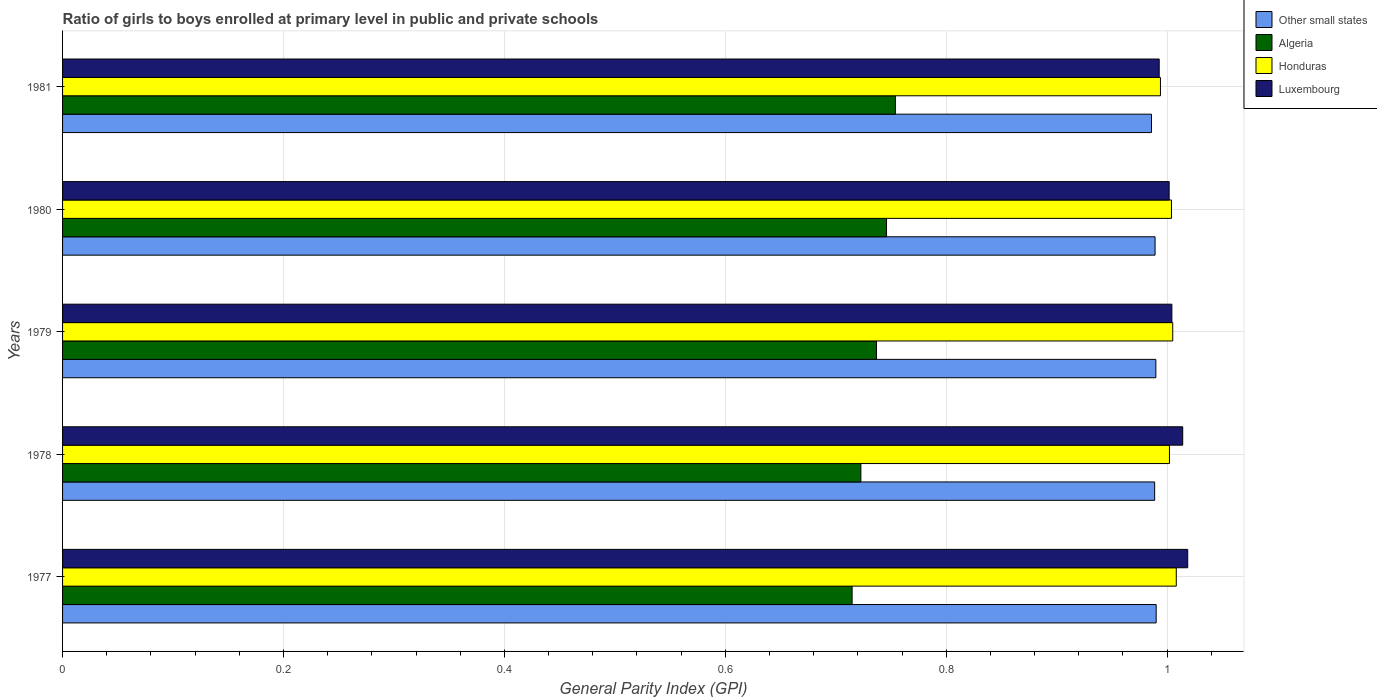How many different coloured bars are there?
Your answer should be very brief. 4. Are the number of bars per tick equal to the number of legend labels?
Offer a very short reply. Yes. How many bars are there on the 2nd tick from the top?
Give a very brief answer. 4. How many bars are there on the 2nd tick from the bottom?
Make the answer very short. 4. What is the label of the 4th group of bars from the top?
Give a very brief answer. 1978. In how many cases, is the number of bars for a given year not equal to the number of legend labels?
Keep it short and to the point. 0. What is the general parity index in Honduras in 1979?
Your answer should be compact. 1.01. Across all years, what is the maximum general parity index in Other small states?
Your answer should be very brief. 0.99. Across all years, what is the minimum general parity index in Honduras?
Keep it short and to the point. 0.99. In which year was the general parity index in Other small states maximum?
Offer a terse response. 1977. In which year was the general parity index in Luxembourg minimum?
Your answer should be compact. 1981. What is the total general parity index in Algeria in the graph?
Provide a succinct answer. 3.67. What is the difference between the general parity index in Honduras in 1979 and that in 1981?
Keep it short and to the point. 0.01. What is the difference between the general parity index in Other small states in 1979 and the general parity index in Luxembourg in 1978?
Your response must be concise. -0.02. What is the average general parity index in Luxembourg per year?
Your answer should be compact. 1.01. In the year 1979, what is the difference between the general parity index in Honduras and general parity index in Algeria?
Provide a succinct answer. 0.27. What is the ratio of the general parity index in Algeria in 1977 to that in 1981?
Make the answer very short. 0.95. Is the general parity index in Algeria in 1977 less than that in 1978?
Offer a very short reply. Yes. What is the difference between the highest and the second highest general parity index in Algeria?
Offer a terse response. 0.01. What is the difference between the highest and the lowest general parity index in Other small states?
Your answer should be very brief. 0. What does the 4th bar from the top in 1981 represents?
Provide a succinct answer. Other small states. What does the 1st bar from the bottom in 1979 represents?
Your response must be concise. Other small states. Is it the case that in every year, the sum of the general parity index in Other small states and general parity index in Algeria is greater than the general parity index in Honduras?
Offer a very short reply. Yes. How many bars are there?
Make the answer very short. 20. Are all the bars in the graph horizontal?
Ensure brevity in your answer.  Yes. How many years are there in the graph?
Offer a terse response. 5. What is the difference between two consecutive major ticks on the X-axis?
Your response must be concise. 0.2. Are the values on the major ticks of X-axis written in scientific E-notation?
Ensure brevity in your answer.  No. Does the graph contain any zero values?
Your response must be concise. No. Does the graph contain grids?
Your answer should be compact. Yes. Where does the legend appear in the graph?
Your answer should be very brief. Top right. What is the title of the graph?
Keep it short and to the point. Ratio of girls to boys enrolled at primary level in public and private schools. Does "French Polynesia" appear as one of the legend labels in the graph?
Provide a succinct answer. No. What is the label or title of the X-axis?
Offer a terse response. General Parity Index (GPI). What is the label or title of the Y-axis?
Ensure brevity in your answer.  Years. What is the General Parity Index (GPI) of Other small states in 1977?
Ensure brevity in your answer.  0.99. What is the General Parity Index (GPI) of Algeria in 1977?
Offer a terse response. 0.71. What is the General Parity Index (GPI) of Honduras in 1977?
Ensure brevity in your answer.  1.01. What is the General Parity Index (GPI) in Luxembourg in 1977?
Provide a succinct answer. 1.02. What is the General Parity Index (GPI) in Other small states in 1978?
Provide a succinct answer. 0.99. What is the General Parity Index (GPI) of Algeria in 1978?
Provide a succinct answer. 0.72. What is the General Parity Index (GPI) in Honduras in 1978?
Your response must be concise. 1. What is the General Parity Index (GPI) of Luxembourg in 1978?
Provide a short and direct response. 1.01. What is the General Parity Index (GPI) in Other small states in 1979?
Offer a very short reply. 0.99. What is the General Parity Index (GPI) of Algeria in 1979?
Make the answer very short. 0.74. What is the General Parity Index (GPI) of Honduras in 1979?
Provide a succinct answer. 1.01. What is the General Parity Index (GPI) of Luxembourg in 1979?
Keep it short and to the point. 1. What is the General Parity Index (GPI) of Other small states in 1980?
Ensure brevity in your answer.  0.99. What is the General Parity Index (GPI) of Algeria in 1980?
Offer a very short reply. 0.75. What is the General Parity Index (GPI) of Honduras in 1980?
Offer a very short reply. 1. What is the General Parity Index (GPI) of Luxembourg in 1980?
Offer a terse response. 1. What is the General Parity Index (GPI) of Other small states in 1981?
Make the answer very short. 0.99. What is the General Parity Index (GPI) of Algeria in 1981?
Your response must be concise. 0.75. What is the General Parity Index (GPI) in Honduras in 1981?
Provide a succinct answer. 0.99. What is the General Parity Index (GPI) in Luxembourg in 1981?
Ensure brevity in your answer.  0.99. Across all years, what is the maximum General Parity Index (GPI) in Other small states?
Offer a very short reply. 0.99. Across all years, what is the maximum General Parity Index (GPI) in Algeria?
Make the answer very short. 0.75. Across all years, what is the maximum General Parity Index (GPI) of Honduras?
Provide a short and direct response. 1.01. Across all years, what is the maximum General Parity Index (GPI) of Luxembourg?
Keep it short and to the point. 1.02. Across all years, what is the minimum General Parity Index (GPI) of Other small states?
Your answer should be compact. 0.99. Across all years, what is the minimum General Parity Index (GPI) of Algeria?
Keep it short and to the point. 0.71. Across all years, what is the minimum General Parity Index (GPI) of Honduras?
Ensure brevity in your answer.  0.99. Across all years, what is the minimum General Parity Index (GPI) in Luxembourg?
Make the answer very short. 0.99. What is the total General Parity Index (GPI) in Other small states in the graph?
Make the answer very short. 4.94. What is the total General Parity Index (GPI) in Algeria in the graph?
Offer a very short reply. 3.67. What is the total General Parity Index (GPI) in Honduras in the graph?
Your answer should be compact. 5.01. What is the total General Parity Index (GPI) of Luxembourg in the graph?
Your response must be concise. 5.03. What is the difference between the General Parity Index (GPI) in Other small states in 1977 and that in 1978?
Offer a very short reply. 0. What is the difference between the General Parity Index (GPI) in Algeria in 1977 and that in 1978?
Your answer should be very brief. -0.01. What is the difference between the General Parity Index (GPI) in Honduras in 1977 and that in 1978?
Your answer should be very brief. 0.01. What is the difference between the General Parity Index (GPI) of Luxembourg in 1977 and that in 1978?
Keep it short and to the point. 0. What is the difference between the General Parity Index (GPI) of Algeria in 1977 and that in 1979?
Your answer should be compact. -0.02. What is the difference between the General Parity Index (GPI) of Honduras in 1977 and that in 1979?
Provide a succinct answer. 0. What is the difference between the General Parity Index (GPI) of Luxembourg in 1977 and that in 1979?
Offer a terse response. 0.01. What is the difference between the General Parity Index (GPI) of Other small states in 1977 and that in 1980?
Make the answer very short. 0. What is the difference between the General Parity Index (GPI) in Algeria in 1977 and that in 1980?
Offer a terse response. -0.03. What is the difference between the General Parity Index (GPI) of Honduras in 1977 and that in 1980?
Make the answer very short. 0. What is the difference between the General Parity Index (GPI) of Luxembourg in 1977 and that in 1980?
Your answer should be compact. 0.02. What is the difference between the General Parity Index (GPI) in Other small states in 1977 and that in 1981?
Give a very brief answer. 0. What is the difference between the General Parity Index (GPI) of Algeria in 1977 and that in 1981?
Provide a short and direct response. -0.04. What is the difference between the General Parity Index (GPI) in Honduras in 1977 and that in 1981?
Your answer should be very brief. 0.01. What is the difference between the General Parity Index (GPI) of Luxembourg in 1977 and that in 1981?
Provide a succinct answer. 0.03. What is the difference between the General Parity Index (GPI) of Other small states in 1978 and that in 1979?
Provide a short and direct response. -0. What is the difference between the General Parity Index (GPI) of Algeria in 1978 and that in 1979?
Provide a short and direct response. -0.01. What is the difference between the General Parity Index (GPI) of Honduras in 1978 and that in 1979?
Offer a terse response. -0. What is the difference between the General Parity Index (GPI) of Luxembourg in 1978 and that in 1979?
Provide a short and direct response. 0.01. What is the difference between the General Parity Index (GPI) in Other small states in 1978 and that in 1980?
Your answer should be very brief. -0. What is the difference between the General Parity Index (GPI) of Algeria in 1978 and that in 1980?
Your response must be concise. -0.02. What is the difference between the General Parity Index (GPI) in Honduras in 1978 and that in 1980?
Your answer should be compact. -0. What is the difference between the General Parity Index (GPI) of Luxembourg in 1978 and that in 1980?
Offer a very short reply. 0.01. What is the difference between the General Parity Index (GPI) in Other small states in 1978 and that in 1981?
Offer a very short reply. 0. What is the difference between the General Parity Index (GPI) of Algeria in 1978 and that in 1981?
Give a very brief answer. -0.03. What is the difference between the General Parity Index (GPI) of Honduras in 1978 and that in 1981?
Ensure brevity in your answer.  0.01. What is the difference between the General Parity Index (GPI) of Luxembourg in 1978 and that in 1981?
Ensure brevity in your answer.  0.02. What is the difference between the General Parity Index (GPI) of Other small states in 1979 and that in 1980?
Ensure brevity in your answer.  0. What is the difference between the General Parity Index (GPI) of Algeria in 1979 and that in 1980?
Your response must be concise. -0.01. What is the difference between the General Parity Index (GPI) in Honduras in 1979 and that in 1980?
Offer a terse response. 0. What is the difference between the General Parity Index (GPI) in Luxembourg in 1979 and that in 1980?
Give a very brief answer. 0. What is the difference between the General Parity Index (GPI) of Other small states in 1979 and that in 1981?
Make the answer very short. 0. What is the difference between the General Parity Index (GPI) of Algeria in 1979 and that in 1981?
Offer a very short reply. -0.02. What is the difference between the General Parity Index (GPI) of Honduras in 1979 and that in 1981?
Your response must be concise. 0.01. What is the difference between the General Parity Index (GPI) in Luxembourg in 1979 and that in 1981?
Provide a succinct answer. 0.01. What is the difference between the General Parity Index (GPI) of Other small states in 1980 and that in 1981?
Offer a terse response. 0. What is the difference between the General Parity Index (GPI) of Algeria in 1980 and that in 1981?
Make the answer very short. -0.01. What is the difference between the General Parity Index (GPI) of Honduras in 1980 and that in 1981?
Give a very brief answer. 0.01. What is the difference between the General Parity Index (GPI) of Luxembourg in 1980 and that in 1981?
Your response must be concise. 0.01. What is the difference between the General Parity Index (GPI) in Other small states in 1977 and the General Parity Index (GPI) in Algeria in 1978?
Ensure brevity in your answer.  0.27. What is the difference between the General Parity Index (GPI) of Other small states in 1977 and the General Parity Index (GPI) of Honduras in 1978?
Give a very brief answer. -0.01. What is the difference between the General Parity Index (GPI) in Other small states in 1977 and the General Parity Index (GPI) in Luxembourg in 1978?
Give a very brief answer. -0.02. What is the difference between the General Parity Index (GPI) of Algeria in 1977 and the General Parity Index (GPI) of Honduras in 1978?
Give a very brief answer. -0.29. What is the difference between the General Parity Index (GPI) in Algeria in 1977 and the General Parity Index (GPI) in Luxembourg in 1978?
Offer a very short reply. -0.3. What is the difference between the General Parity Index (GPI) of Honduras in 1977 and the General Parity Index (GPI) of Luxembourg in 1978?
Provide a short and direct response. -0.01. What is the difference between the General Parity Index (GPI) of Other small states in 1977 and the General Parity Index (GPI) of Algeria in 1979?
Make the answer very short. 0.25. What is the difference between the General Parity Index (GPI) of Other small states in 1977 and the General Parity Index (GPI) of Honduras in 1979?
Your response must be concise. -0.01. What is the difference between the General Parity Index (GPI) of Other small states in 1977 and the General Parity Index (GPI) of Luxembourg in 1979?
Make the answer very short. -0.01. What is the difference between the General Parity Index (GPI) of Algeria in 1977 and the General Parity Index (GPI) of Honduras in 1979?
Your answer should be compact. -0.29. What is the difference between the General Parity Index (GPI) of Algeria in 1977 and the General Parity Index (GPI) of Luxembourg in 1979?
Your answer should be compact. -0.29. What is the difference between the General Parity Index (GPI) in Honduras in 1977 and the General Parity Index (GPI) in Luxembourg in 1979?
Offer a terse response. 0. What is the difference between the General Parity Index (GPI) in Other small states in 1977 and the General Parity Index (GPI) in Algeria in 1980?
Offer a terse response. 0.24. What is the difference between the General Parity Index (GPI) in Other small states in 1977 and the General Parity Index (GPI) in Honduras in 1980?
Your response must be concise. -0.01. What is the difference between the General Parity Index (GPI) in Other small states in 1977 and the General Parity Index (GPI) in Luxembourg in 1980?
Your response must be concise. -0.01. What is the difference between the General Parity Index (GPI) of Algeria in 1977 and the General Parity Index (GPI) of Honduras in 1980?
Make the answer very short. -0.29. What is the difference between the General Parity Index (GPI) of Algeria in 1977 and the General Parity Index (GPI) of Luxembourg in 1980?
Offer a terse response. -0.29. What is the difference between the General Parity Index (GPI) of Honduras in 1977 and the General Parity Index (GPI) of Luxembourg in 1980?
Ensure brevity in your answer.  0.01. What is the difference between the General Parity Index (GPI) of Other small states in 1977 and the General Parity Index (GPI) of Algeria in 1981?
Provide a short and direct response. 0.24. What is the difference between the General Parity Index (GPI) of Other small states in 1977 and the General Parity Index (GPI) of Honduras in 1981?
Provide a succinct answer. -0. What is the difference between the General Parity Index (GPI) in Other small states in 1977 and the General Parity Index (GPI) in Luxembourg in 1981?
Your answer should be compact. -0. What is the difference between the General Parity Index (GPI) in Algeria in 1977 and the General Parity Index (GPI) in Honduras in 1981?
Your response must be concise. -0.28. What is the difference between the General Parity Index (GPI) of Algeria in 1977 and the General Parity Index (GPI) of Luxembourg in 1981?
Give a very brief answer. -0.28. What is the difference between the General Parity Index (GPI) of Honduras in 1977 and the General Parity Index (GPI) of Luxembourg in 1981?
Ensure brevity in your answer.  0.02. What is the difference between the General Parity Index (GPI) in Other small states in 1978 and the General Parity Index (GPI) in Algeria in 1979?
Your response must be concise. 0.25. What is the difference between the General Parity Index (GPI) in Other small states in 1978 and the General Parity Index (GPI) in Honduras in 1979?
Ensure brevity in your answer.  -0.02. What is the difference between the General Parity Index (GPI) of Other small states in 1978 and the General Parity Index (GPI) of Luxembourg in 1979?
Offer a very short reply. -0.02. What is the difference between the General Parity Index (GPI) in Algeria in 1978 and the General Parity Index (GPI) in Honduras in 1979?
Offer a very short reply. -0.28. What is the difference between the General Parity Index (GPI) of Algeria in 1978 and the General Parity Index (GPI) of Luxembourg in 1979?
Your answer should be very brief. -0.28. What is the difference between the General Parity Index (GPI) of Honduras in 1978 and the General Parity Index (GPI) of Luxembourg in 1979?
Your answer should be very brief. -0. What is the difference between the General Parity Index (GPI) in Other small states in 1978 and the General Parity Index (GPI) in Algeria in 1980?
Provide a short and direct response. 0.24. What is the difference between the General Parity Index (GPI) of Other small states in 1978 and the General Parity Index (GPI) of Honduras in 1980?
Offer a very short reply. -0.02. What is the difference between the General Parity Index (GPI) of Other small states in 1978 and the General Parity Index (GPI) of Luxembourg in 1980?
Your answer should be very brief. -0.01. What is the difference between the General Parity Index (GPI) in Algeria in 1978 and the General Parity Index (GPI) in Honduras in 1980?
Offer a terse response. -0.28. What is the difference between the General Parity Index (GPI) in Algeria in 1978 and the General Parity Index (GPI) in Luxembourg in 1980?
Offer a very short reply. -0.28. What is the difference between the General Parity Index (GPI) of Honduras in 1978 and the General Parity Index (GPI) of Luxembourg in 1980?
Keep it short and to the point. 0. What is the difference between the General Parity Index (GPI) of Other small states in 1978 and the General Parity Index (GPI) of Algeria in 1981?
Ensure brevity in your answer.  0.23. What is the difference between the General Parity Index (GPI) in Other small states in 1978 and the General Parity Index (GPI) in Honduras in 1981?
Offer a very short reply. -0.01. What is the difference between the General Parity Index (GPI) of Other small states in 1978 and the General Parity Index (GPI) of Luxembourg in 1981?
Your answer should be compact. -0. What is the difference between the General Parity Index (GPI) of Algeria in 1978 and the General Parity Index (GPI) of Honduras in 1981?
Your response must be concise. -0.27. What is the difference between the General Parity Index (GPI) of Algeria in 1978 and the General Parity Index (GPI) of Luxembourg in 1981?
Make the answer very short. -0.27. What is the difference between the General Parity Index (GPI) of Honduras in 1978 and the General Parity Index (GPI) of Luxembourg in 1981?
Offer a very short reply. 0.01. What is the difference between the General Parity Index (GPI) of Other small states in 1979 and the General Parity Index (GPI) of Algeria in 1980?
Your response must be concise. 0.24. What is the difference between the General Parity Index (GPI) in Other small states in 1979 and the General Parity Index (GPI) in Honduras in 1980?
Give a very brief answer. -0.01. What is the difference between the General Parity Index (GPI) of Other small states in 1979 and the General Parity Index (GPI) of Luxembourg in 1980?
Provide a short and direct response. -0.01. What is the difference between the General Parity Index (GPI) in Algeria in 1979 and the General Parity Index (GPI) in Honduras in 1980?
Offer a very short reply. -0.27. What is the difference between the General Parity Index (GPI) in Algeria in 1979 and the General Parity Index (GPI) in Luxembourg in 1980?
Ensure brevity in your answer.  -0.27. What is the difference between the General Parity Index (GPI) of Honduras in 1979 and the General Parity Index (GPI) of Luxembourg in 1980?
Offer a very short reply. 0. What is the difference between the General Parity Index (GPI) of Other small states in 1979 and the General Parity Index (GPI) of Algeria in 1981?
Offer a very short reply. 0.24. What is the difference between the General Parity Index (GPI) of Other small states in 1979 and the General Parity Index (GPI) of Honduras in 1981?
Make the answer very short. -0. What is the difference between the General Parity Index (GPI) of Other small states in 1979 and the General Parity Index (GPI) of Luxembourg in 1981?
Make the answer very short. -0. What is the difference between the General Parity Index (GPI) of Algeria in 1979 and the General Parity Index (GPI) of Honduras in 1981?
Your answer should be compact. -0.26. What is the difference between the General Parity Index (GPI) of Algeria in 1979 and the General Parity Index (GPI) of Luxembourg in 1981?
Provide a short and direct response. -0.26. What is the difference between the General Parity Index (GPI) of Honduras in 1979 and the General Parity Index (GPI) of Luxembourg in 1981?
Your answer should be compact. 0.01. What is the difference between the General Parity Index (GPI) of Other small states in 1980 and the General Parity Index (GPI) of Algeria in 1981?
Give a very brief answer. 0.24. What is the difference between the General Parity Index (GPI) in Other small states in 1980 and the General Parity Index (GPI) in Honduras in 1981?
Provide a short and direct response. -0. What is the difference between the General Parity Index (GPI) in Other small states in 1980 and the General Parity Index (GPI) in Luxembourg in 1981?
Provide a succinct answer. -0. What is the difference between the General Parity Index (GPI) of Algeria in 1980 and the General Parity Index (GPI) of Honduras in 1981?
Keep it short and to the point. -0.25. What is the difference between the General Parity Index (GPI) in Algeria in 1980 and the General Parity Index (GPI) in Luxembourg in 1981?
Offer a very short reply. -0.25. What is the difference between the General Parity Index (GPI) of Honduras in 1980 and the General Parity Index (GPI) of Luxembourg in 1981?
Your answer should be compact. 0.01. What is the average General Parity Index (GPI) of Other small states per year?
Your response must be concise. 0.99. What is the average General Parity Index (GPI) in Algeria per year?
Ensure brevity in your answer.  0.73. In the year 1977, what is the difference between the General Parity Index (GPI) of Other small states and General Parity Index (GPI) of Algeria?
Give a very brief answer. 0.28. In the year 1977, what is the difference between the General Parity Index (GPI) of Other small states and General Parity Index (GPI) of Honduras?
Your answer should be compact. -0.02. In the year 1977, what is the difference between the General Parity Index (GPI) in Other small states and General Parity Index (GPI) in Luxembourg?
Ensure brevity in your answer.  -0.03. In the year 1977, what is the difference between the General Parity Index (GPI) of Algeria and General Parity Index (GPI) of Honduras?
Your answer should be compact. -0.29. In the year 1977, what is the difference between the General Parity Index (GPI) in Algeria and General Parity Index (GPI) in Luxembourg?
Your answer should be compact. -0.3. In the year 1977, what is the difference between the General Parity Index (GPI) in Honduras and General Parity Index (GPI) in Luxembourg?
Give a very brief answer. -0.01. In the year 1978, what is the difference between the General Parity Index (GPI) of Other small states and General Parity Index (GPI) of Algeria?
Offer a terse response. 0.27. In the year 1978, what is the difference between the General Parity Index (GPI) in Other small states and General Parity Index (GPI) in Honduras?
Provide a succinct answer. -0.01. In the year 1978, what is the difference between the General Parity Index (GPI) in Other small states and General Parity Index (GPI) in Luxembourg?
Your answer should be compact. -0.03. In the year 1978, what is the difference between the General Parity Index (GPI) in Algeria and General Parity Index (GPI) in Honduras?
Your answer should be compact. -0.28. In the year 1978, what is the difference between the General Parity Index (GPI) in Algeria and General Parity Index (GPI) in Luxembourg?
Provide a short and direct response. -0.29. In the year 1978, what is the difference between the General Parity Index (GPI) in Honduras and General Parity Index (GPI) in Luxembourg?
Offer a very short reply. -0.01. In the year 1979, what is the difference between the General Parity Index (GPI) of Other small states and General Parity Index (GPI) of Algeria?
Provide a succinct answer. 0.25. In the year 1979, what is the difference between the General Parity Index (GPI) of Other small states and General Parity Index (GPI) of Honduras?
Ensure brevity in your answer.  -0.02. In the year 1979, what is the difference between the General Parity Index (GPI) of Other small states and General Parity Index (GPI) of Luxembourg?
Keep it short and to the point. -0.01. In the year 1979, what is the difference between the General Parity Index (GPI) in Algeria and General Parity Index (GPI) in Honduras?
Provide a short and direct response. -0.27. In the year 1979, what is the difference between the General Parity Index (GPI) of Algeria and General Parity Index (GPI) of Luxembourg?
Keep it short and to the point. -0.27. In the year 1979, what is the difference between the General Parity Index (GPI) of Honduras and General Parity Index (GPI) of Luxembourg?
Ensure brevity in your answer.  0. In the year 1980, what is the difference between the General Parity Index (GPI) of Other small states and General Parity Index (GPI) of Algeria?
Keep it short and to the point. 0.24. In the year 1980, what is the difference between the General Parity Index (GPI) in Other small states and General Parity Index (GPI) in Honduras?
Ensure brevity in your answer.  -0.01. In the year 1980, what is the difference between the General Parity Index (GPI) in Other small states and General Parity Index (GPI) in Luxembourg?
Keep it short and to the point. -0.01. In the year 1980, what is the difference between the General Parity Index (GPI) in Algeria and General Parity Index (GPI) in Honduras?
Offer a very short reply. -0.26. In the year 1980, what is the difference between the General Parity Index (GPI) in Algeria and General Parity Index (GPI) in Luxembourg?
Make the answer very short. -0.26. In the year 1980, what is the difference between the General Parity Index (GPI) of Honduras and General Parity Index (GPI) of Luxembourg?
Provide a succinct answer. 0. In the year 1981, what is the difference between the General Parity Index (GPI) of Other small states and General Parity Index (GPI) of Algeria?
Your response must be concise. 0.23. In the year 1981, what is the difference between the General Parity Index (GPI) in Other small states and General Parity Index (GPI) in Honduras?
Offer a terse response. -0.01. In the year 1981, what is the difference between the General Parity Index (GPI) in Other small states and General Parity Index (GPI) in Luxembourg?
Keep it short and to the point. -0.01. In the year 1981, what is the difference between the General Parity Index (GPI) of Algeria and General Parity Index (GPI) of Honduras?
Your answer should be very brief. -0.24. In the year 1981, what is the difference between the General Parity Index (GPI) of Algeria and General Parity Index (GPI) of Luxembourg?
Your response must be concise. -0.24. In the year 1981, what is the difference between the General Parity Index (GPI) of Honduras and General Parity Index (GPI) of Luxembourg?
Your response must be concise. 0. What is the ratio of the General Parity Index (GPI) in Other small states in 1977 to that in 1978?
Offer a very short reply. 1. What is the ratio of the General Parity Index (GPI) in Algeria in 1977 to that in 1978?
Keep it short and to the point. 0.99. What is the ratio of the General Parity Index (GPI) in Honduras in 1977 to that in 1978?
Ensure brevity in your answer.  1.01. What is the ratio of the General Parity Index (GPI) of Luxembourg in 1977 to that in 1978?
Provide a succinct answer. 1. What is the ratio of the General Parity Index (GPI) of Other small states in 1977 to that in 1979?
Offer a terse response. 1. What is the ratio of the General Parity Index (GPI) of Algeria in 1977 to that in 1979?
Ensure brevity in your answer.  0.97. What is the ratio of the General Parity Index (GPI) in Honduras in 1977 to that in 1979?
Offer a terse response. 1. What is the ratio of the General Parity Index (GPI) in Luxembourg in 1977 to that in 1979?
Provide a short and direct response. 1.01. What is the ratio of the General Parity Index (GPI) in Other small states in 1977 to that in 1980?
Provide a short and direct response. 1. What is the ratio of the General Parity Index (GPI) in Algeria in 1977 to that in 1980?
Your answer should be very brief. 0.96. What is the ratio of the General Parity Index (GPI) in Luxembourg in 1977 to that in 1980?
Keep it short and to the point. 1.02. What is the ratio of the General Parity Index (GPI) of Other small states in 1977 to that in 1981?
Give a very brief answer. 1. What is the ratio of the General Parity Index (GPI) of Algeria in 1977 to that in 1981?
Offer a terse response. 0.95. What is the ratio of the General Parity Index (GPI) of Honduras in 1977 to that in 1981?
Offer a very short reply. 1.01. What is the ratio of the General Parity Index (GPI) of Algeria in 1978 to that in 1979?
Your answer should be compact. 0.98. What is the ratio of the General Parity Index (GPI) of Luxembourg in 1978 to that in 1979?
Your answer should be very brief. 1.01. What is the ratio of the General Parity Index (GPI) in Other small states in 1978 to that in 1980?
Provide a short and direct response. 1. What is the ratio of the General Parity Index (GPI) in Algeria in 1978 to that in 1980?
Provide a short and direct response. 0.97. What is the ratio of the General Parity Index (GPI) of Honduras in 1978 to that in 1980?
Offer a terse response. 1. What is the ratio of the General Parity Index (GPI) in Luxembourg in 1978 to that in 1980?
Make the answer very short. 1.01. What is the ratio of the General Parity Index (GPI) in Other small states in 1978 to that in 1981?
Your answer should be compact. 1. What is the ratio of the General Parity Index (GPI) in Algeria in 1978 to that in 1981?
Ensure brevity in your answer.  0.96. What is the ratio of the General Parity Index (GPI) in Honduras in 1978 to that in 1981?
Make the answer very short. 1.01. What is the ratio of the General Parity Index (GPI) of Luxembourg in 1978 to that in 1981?
Your answer should be compact. 1.02. What is the ratio of the General Parity Index (GPI) of Other small states in 1979 to that in 1980?
Offer a terse response. 1. What is the ratio of the General Parity Index (GPI) of Honduras in 1979 to that in 1980?
Offer a terse response. 1. What is the ratio of the General Parity Index (GPI) of Algeria in 1979 to that in 1981?
Provide a succinct answer. 0.98. What is the ratio of the General Parity Index (GPI) of Honduras in 1979 to that in 1981?
Offer a very short reply. 1.01. What is the ratio of the General Parity Index (GPI) in Luxembourg in 1979 to that in 1981?
Offer a very short reply. 1.01. What is the ratio of the General Parity Index (GPI) of Algeria in 1980 to that in 1981?
Provide a succinct answer. 0.99. What is the ratio of the General Parity Index (GPI) in Luxembourg in 1980 to that in 1981?
Ensure brevity in your answer.  1.01. What is the difference between the highest and the second highest General Parity Index (GPI) of Other small states?
Your answer should be compact. 0. What is the difference between the highest and the second highest General Parity Index (GPI) in Algeria?
Provide a short and direct response. 0.01. What is the difference between the highest and the second highest General Parity Index (GPI) of Honduras?
Offer a terse response. 0. What is the difference between the highest and the second highest General Parity Index (GPI) of Luxembourg?
Give a very brief answer. 0. What is the difference between the highest and the lowest General Parity Index (GPI) of Other small states?
Make the answer very short. 0. What is the difference between the highest and the lowest General Parity Index (GPI) of Algeria?
Your answer should be very brief. 0.04. What is the difference between the highest and the lowest General Parity Index (GPI) of Honduras?
Give a very brief answer. 0.01. What is the difference between the highest and the lowest General Parity Index (GPI) in Luxembourg?
Your answer should be very brief. 0.03. 